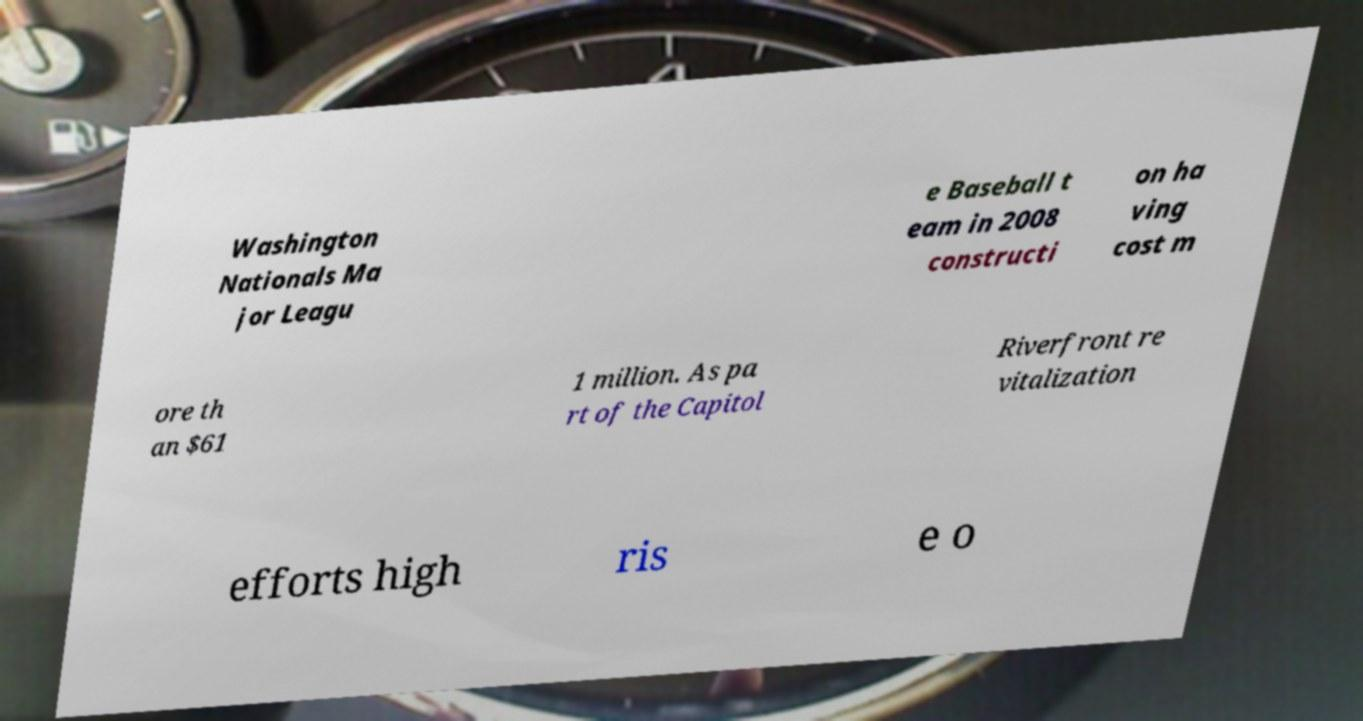I need the written content from this picture converted into text. Can you do that? Washington Nationals Ma jor Leagu e Baseball t eam in 2008 constructi on ha ving cost m ore th an $61 1 million. As pa rt of the Capitol Riverfront re vitalization efforts high ris e o 